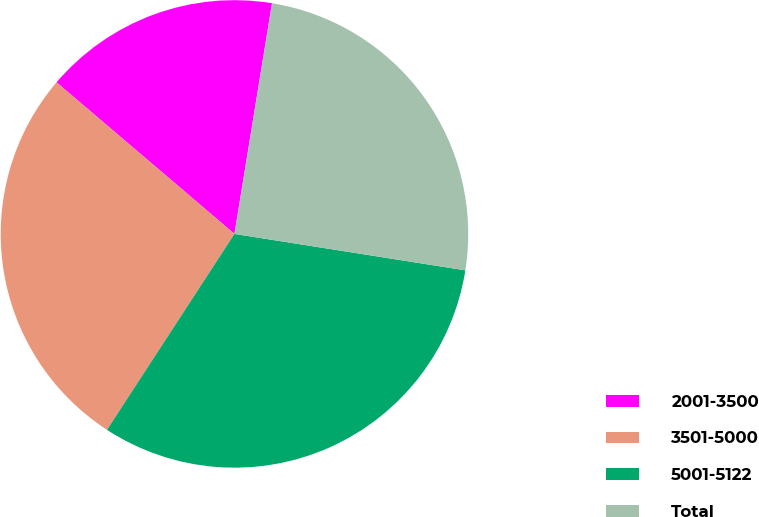Convert chart. <chart><loc_0><loc_0><loc_500><loc_500><pie_chart><fcel>2001-3500<fcel>3501-5000<fcel>5001-5122<fcel>Total<nl><fcel>16.34%<fcel>27.05%<fcel>31.69%<fcel>24.92%<nl></chart> 